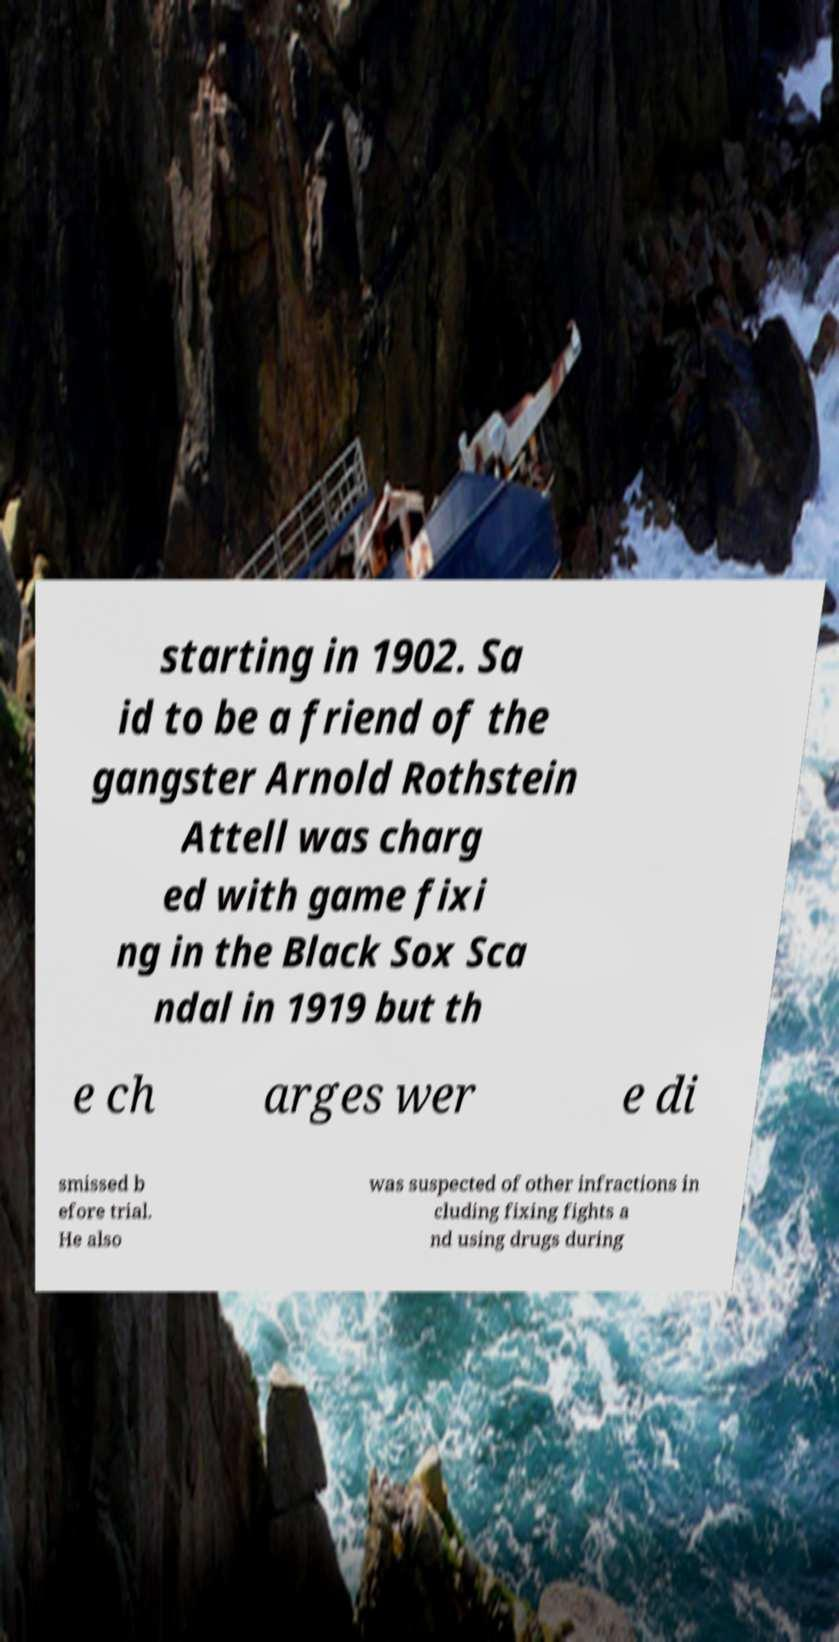Please read and relay the text visible in this image. What does it say? starting in 1902. Sa id to be a friend of the gangster Arnold Rothstein Attell was charg ed with game fixi ng in the Black Sox Sca ndal in 1919 but th e ch arges wer e di smissed b efore trial. He also was suspected of other infractions in cluding fixing fights a nd using drugs during 